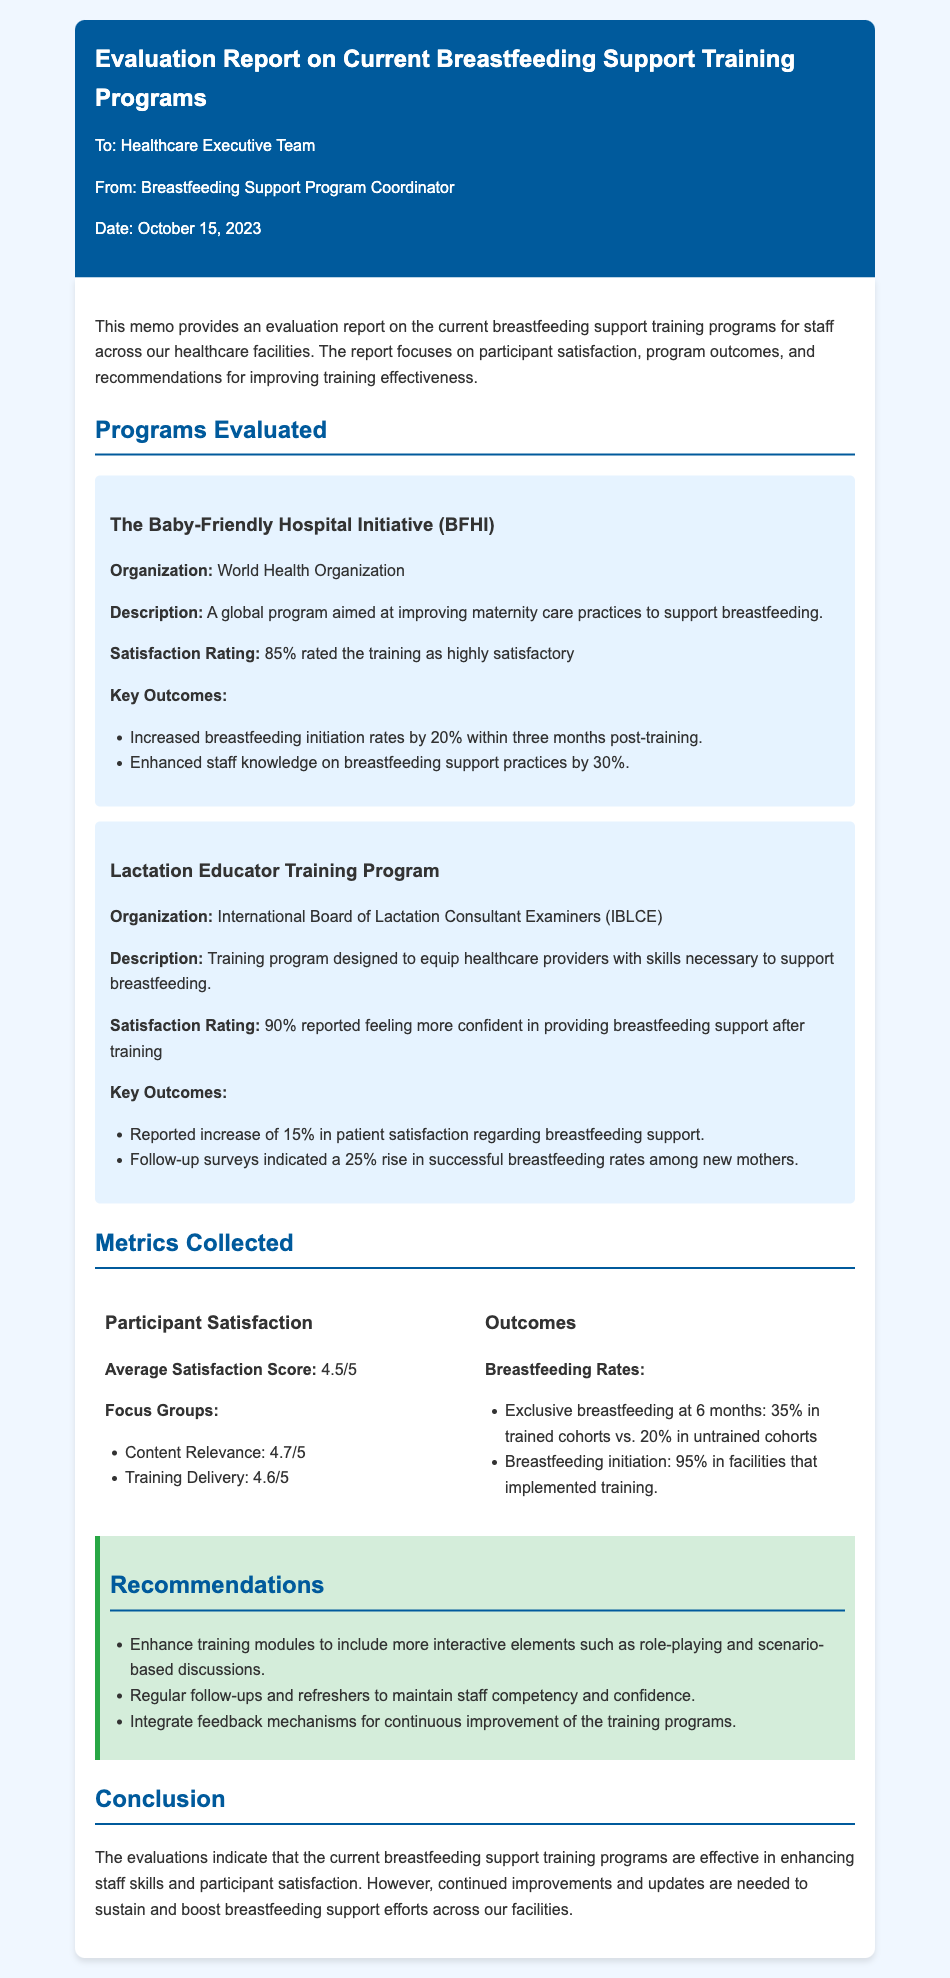What is the average satisfaction score? The average satisfaction score is provided under the participant satisfaction metrics section of the document.
Answer: 4.5/5 What percentage of participants rated the BFHI training as highly satisfactory? The satisfaction rating for the Baby-Friendly Hospital Initiative is mentioned in the program evaluated section.
Answer: 85% What was the increase in breastfeeding initiation rates three months post-training for the BFHI? This information can be found in the key outcomes for the BFHI program section.
Answer: 20% Who organized the Lactation Educator Training Program? The organization responsible for the Lactation Educator Training Program is specified in the program evaluated section.
Answer: International Board of Lactation Consultant Examiners What was the reported percentage increase in successful breastfeeding rates among new mothers after the Lactation Educator Training Program? This figure is detailed in the key outcomes for the Lactation Educator Training Program in the document.
Answer: 25% What is one recommendation made for improving training effectiveness? Recommendations for improving training effectiveness are outlined in a dedicated section of the memo.
Answer: Enhance training modules What was the average satisfaction score for training delivery? This metric is included in the focus groups feedback under participant satisfaction.
Answer: 4.6/5 What is the percentage of exclusive breastfeeding at six months in trained cohorts? This data appears in the outcomes metrics section of the document.
Answer: 35% What is the date of the memo? The date is mentioned at the beginning of the memo, providing the context for the evaluation report.
Answer: October 15, 2023 